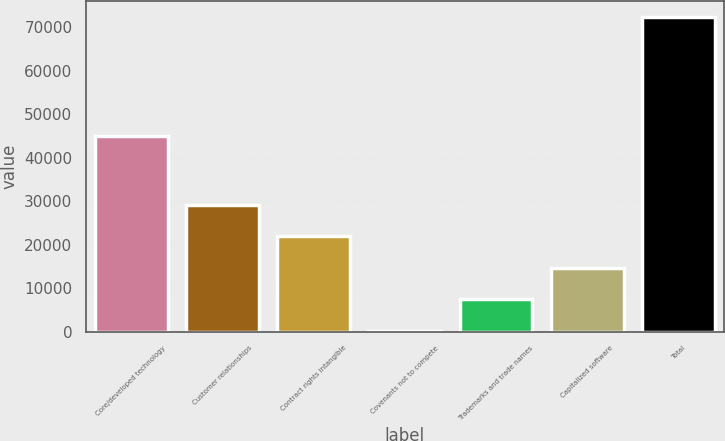Convert chart to OTSL. <chart><loc_0><loc_0><loc_500><loc_500><bar_chart><fcel>Core/developed technology<fcel>Customer relationships<fcel>Contract rights intangible<fcel>Covenants not to compete<fcel>Trademarks and trade names<fcel>Capitalized software<fcel>Total<nl><fcel>44869<fcel>29086.8<fcel>21870.6<fcel>222<fcel>7438.2<fcel>14654.4<fcel>72384<nl></chart> 